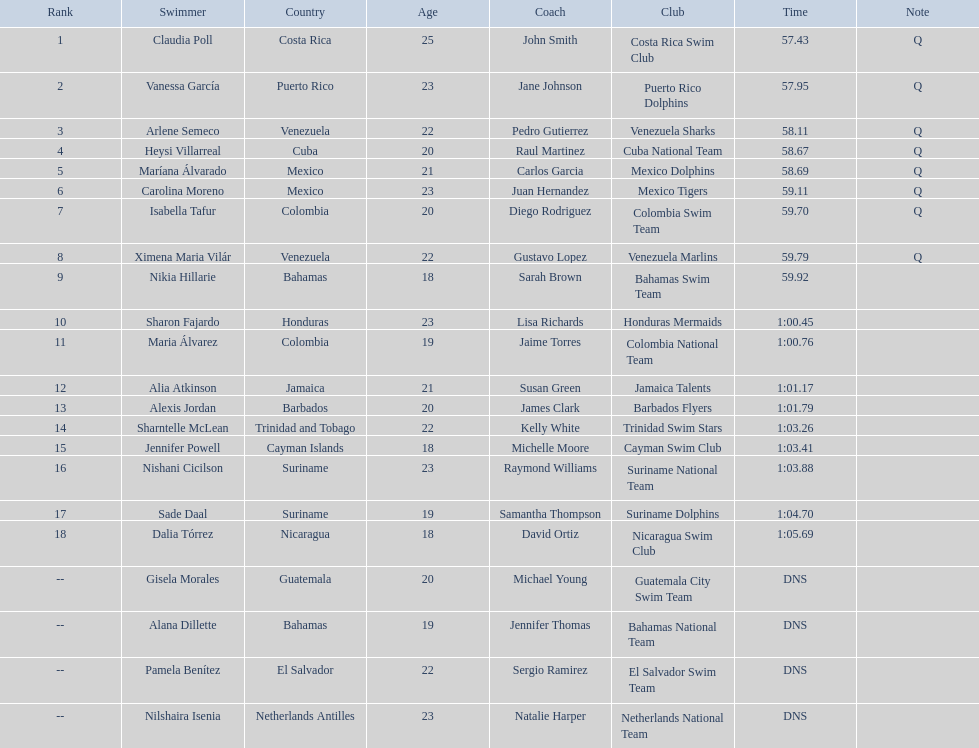How many competitors from venezuela qualified for the final? 2. 